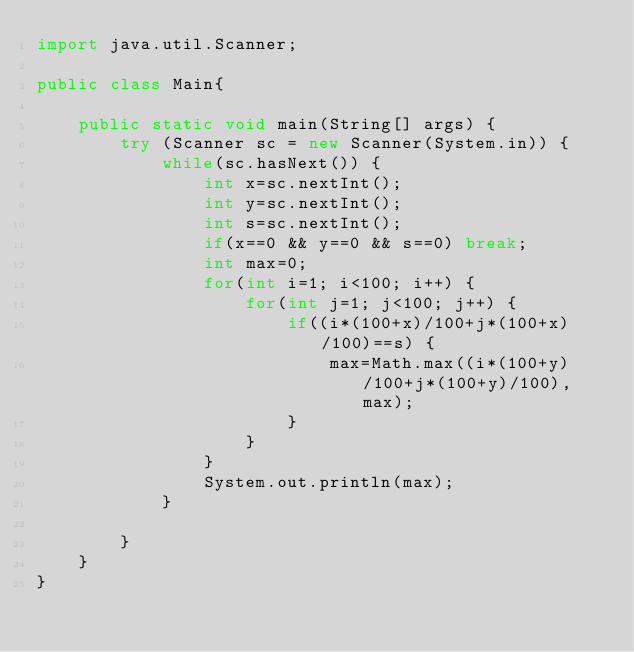Convert code to text. <code><loc_0><loc_0><loc_500><loc_500><_Java_>import java.util.Scanner;

public class Main{
	
	public static void main(String[] args) {
		try (Scanner sc = new Scanner(System.in)) {
			while(sc.hasNext()) {
				int x=sc.nextInt();
				int y=sc.nextInt();
				int s=sc.nextInt();
				if(x==0 && y==0 && s==0) break;
				int max=0;
				for(int i=1; i<100; i++) {
					for(int j=1; j<100; j++) {
						if((i*(100+x)/100+j*(100+x)/100)==s) {
							max=Math.max((i*(100+y)/100+j*(100+y)/100), max);
						}
					}
				}
				System.out.println(max);
			}
			
		}
	}
}
</code> 